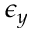Convert formula to latex. <formula><loc_0><loc_0><loc_500><loc_500>\epsilon _ { y }</formula> 